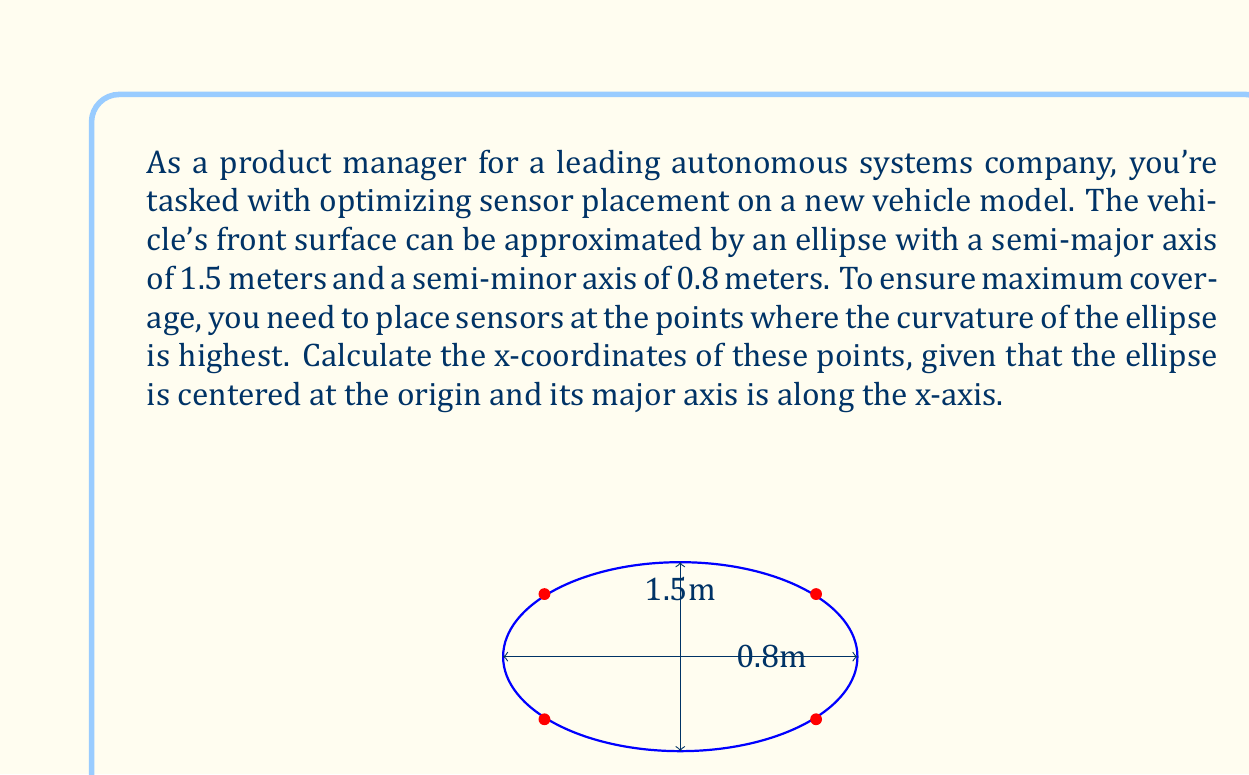Provide a solution to this math problem. To solve this problem, we'll follow these steps:

1) The general equation of an ellipse centered at the origin with semi-major axis $a$ and semi-minor axis $b$ is:

   $$\frac{x^2}{a^2} + \frac{y^2}{b^2} = 1$$

2) In this case, $a = 1.5$ and $b = 0.8$, so our ellipse equation is:

   $$\frac{x^2}{1.5^2} + \frac{y^2}{0.8^2} = 1$$

3) The curvature of an ellipse is given by the formula:

   $$\kappa = \frac{ab}{(a^2\sin^2t + b^2\cos^2t)^{3/2}}$$

   where $t$ is the parameter in the parametric equations of the ellipse:
   $x = a\cos t$, $y = b\sin t$

4) The curvature is maximum where its derivative with respect to $t$ is zero. This occurs at:

   $$t = \arctan\left(\pm\frac{b}{a}\right)$$

5) Substituting our values:

   $$t = \arctan\left(\pm\frac{0.8}{1.5}\right) \approx \pm 0.4899$$

6) To find the x-coordinates, we use $x = a\cos t$:

   $$x = 1.5 \cos(\pm 0.4899) \approx \pm 1.15$$

Therefore, the points of maximum curvature are at $x \approx \pm 1.15$ meters from the center of the ellipse.
Answer: $x \approx \pm 1.15$ meters 